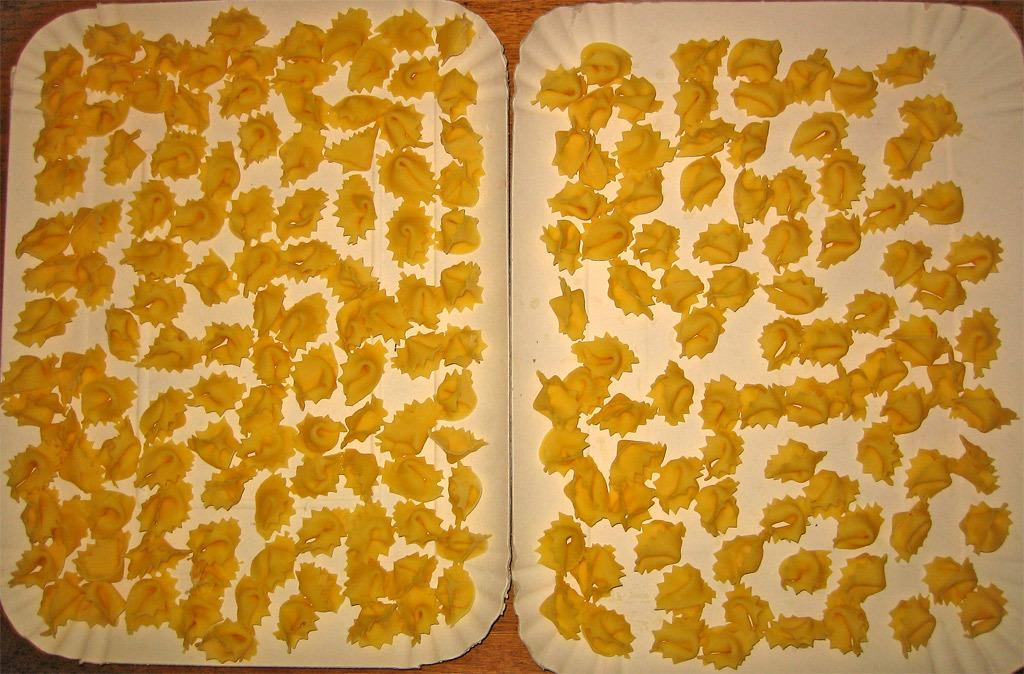What is present in the image related to food? There is food in the image. How are the plates that hold the food colored? The plates are white in color. What is the color of the table on which the plates are placed? The table is brown in color. Is there a cart carrying the food through the wilderness in the image? No, there is no cart or wilderness present in the image. The food is placed on white plates on a brown table. 